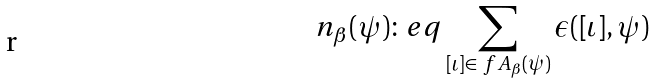Convert formula to latex. <formula><loc_0><loc_0><loc_500><loc_500>n _ { \beta } ( \psi ) \colon e q \sum _ { [ \iota ] \in \ f A _ { \beta } ( \psi ) } \epsilon ( [ \iota ] , \psi )</formula> 